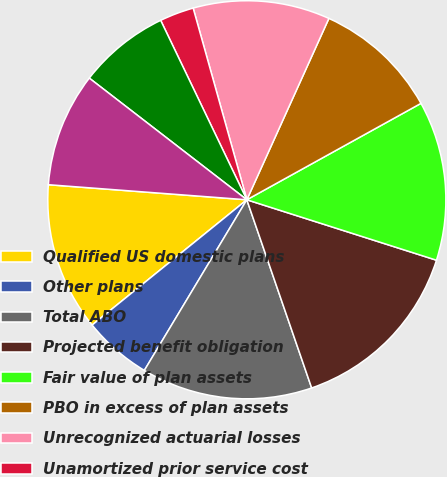Convert chart. <chart><loc_0><loc_0><loc_500><loc_500><pie_chart><fcel>Qualified US domestic plans<fcel>Other plans<fcel>Total ABO<fcel>Projected benefit obligation<fcel>Fair value of plan assets<fcel>PBO in excess of plan assets<fcel>Unrecognized actuarial losses<fcel>Unamortized prior service cost<fcel>Amounts included in balance<fcel>Prepaid pension cost<nl><fcel>12.04%<fcel>5.56%<fcel>13.89%<fcel>14.81%<fcel>12.96%<fcel>10.19%<fcel>11.11%<fcel>2.78%<fcel>7.41%<fcel>9.26%<nl></chart> 